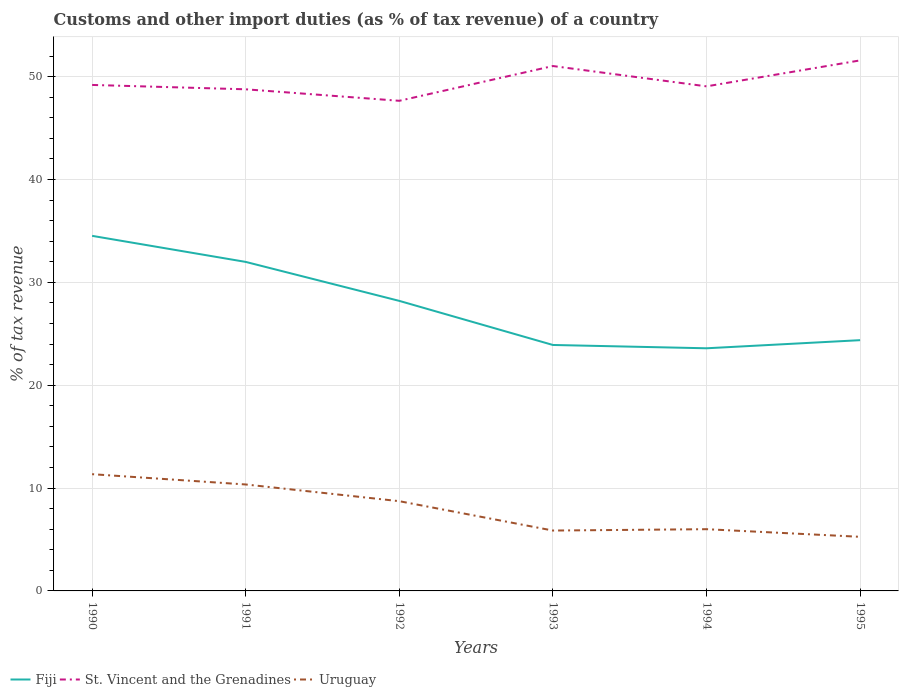Is the number of lines equal to the number of legend labels?
Offer a terse response. Yes. Across all years, what is the maximum percentage of tax revenue from customs in Uruguay?
Your response must be concise. 5.26. What is the total percentage of tax revenue from customs in St. Vincent and the Grenadines in the graph?
Give a very brief answer. -1.84. What is the difference between the highest and the second highest percentage of tax revenue from customs in Fiji?
Offer a very short reply. 10.93. What is the difference between the highest and the lowest percentage of tax revenue from customs in Uruguay?
Keep it short and to the point. 3. Is the percentage of tax revenue from customs in St. Vincent and the Grenadines strictly greater than the percentage of tax revenue from customs in Uruguay over the years?
Your answer should be very brief. No. How many lines are there?
Offer a very short reply. 3. Are the values on the major ticks of Y-axis written in scientific E-notation?
Provide a succinct answer. No. Does the graph contain any zero values?
Provide a short and direct response. No. Does the graph contain grids?
Your answer should be very brief. Yes. Where does the legend appear in the graph?
Ensure brevity in your answer.  Bottom left. What is the title of the graph?
Provide a succinct answer. Customs and other import duties (as % of tax revenue) of a country. What is the label or title of the X-axis?
Give a very brief answer. Years. What is the label or title of the Y-axis?
Your response must be concise. % of tax revenue. What is the % of tax revenue in Fiji in 1990?
Ensure brevity in your answer.  34.53. What is the % of tax revenue in St. Vincent and the Grenadines in 1990?
Offer a terse response. 49.2. What is the % of tax revenue of Uruguay in 1990?
Make the answer very short. 11.35. What is the % of tax revenue in Fiji in 1991?
Your answer should be very brief. 31.99. What is the % of tax revenue of St. Vincent and the Grenadines in 1991?
Keep it short and to the point. 48.78. What is the % of tax revenue of Uruguay in 1991?
Offer a terse response. 10.35. What is the % of tax revenue of Fiji in 1992?
Your response must be concise. 28.2. What is the % of tax revenue in St. Vincent and the Grenadines in 1992?
Your response must be concise. 47.66. What is the % of tax revenue of Uruguay in 1992?
Your answer should be compact. 8.73. What is the % of tax revenue in Fiji in 1993?
Provide a short and direct response. 23.92. What is the % of tax revenue in St. Vincent and the Grenadines in 1993?
Provide a short and direct response. 51.04. What is the % of tax revenue of Uruguay in 1993?
Ensure brevity in your answer.  5.87. What is the % of tax revenue in Fiji in 1994?
Ensure brevity in your answer.  23.59. What is the % of tax revenue in St. Vincent and the Grenadines in 1994?
Provide a short and direct response. 49.06. What is the % of tax revenue of Uruguay in 1994?
Your answer should be compact. 6. What is the % of tax revenue in Fiji in 1995?
Provide a succinct answer. 24.38. What is the % of tax revenue of St. Vincent and the Grenadines in 1995?
Provide a succinct answer. 51.59. What is the % of tax revenue of Uruguay in 1995?
Provide a succinct answer. 5.26. Across all years, what is the maximum % of tax revenue in Fiji?
Make the answer very short. 34.53. Across all years, what is the maximum % of tax revenue of St. Vincent and the Grenadines?
Give a very brief answer. 51.59. Across all years, what is the maximum % of tax revenue of Uruguay?
Ensure brevity in your answer.  11.35. Across all years, what is the minimum % of tax revenue in Fiji?
Provide a succinct answer. 23.59. Across all years, what is the minimum % of tax revenue of St. Vincent and the Grenadines?
Keep it short and to the point. 47.66. Across all years, what is the minimum % of tax revenue in Uruguay?
Offer a terse response. 5.26. What is the total % of tax revenue of Fiji in the graph?
Make the answer very short. 166.61. What is the total % of tax revenue of St. Vincent and the Grenadines in the graph?
Ensure brevity in your answer.  297.31. What is the total % of tax revenue of Uruguay in the graph?
Provide a succinct answer. 47.56. What is the difference between the % of tax revenue in Fiji in 1990 and that in 1991?
Your response must be concise. 2.53. What is the difference between the % of tax revenue of St. Vincent and the Grenadines in 1990 and that in 1991?
Your answer should be compact. 0.42. What is the difference between the % of tax revenue of Uruguay in 1990 and that in 1991?
Your answer should be very brief. 1. What is the difference between the % of tax revenue of Fiji in 1990 and that in 1992?
Provide a succinct answer. 6.32. What is the difference between the % of tax revenue of St. Vincent and the Grenadines in 1990 and that in 1992?
Your response must be concise. 1.54. What is the difference between the % of tax revenue in Uruguay in 1990 and that in 1992?
Offer a very short reply. 2.63. What is the difference between the % of tax revenue of Fiji in 1990 and that in 1993?
Ensure brevity in your answer.  10.61. What is the difference between the % of tax revenue of St. Vincent and the Grenadines in 1990 and that in 1993?
Provide a succinct answer. -1.84. What is the difference between the % of tax revenue in Uruguay in 1990 and that in 1993?
Provide a short and direct response. 5.48. What is the difference between the % of tax revenue in Fiji in 1990 and that in 1994?
Provide a short and direct response. 10.93. What is the difference between the % of tax revenue of St. Vincent and the Grenadines in 1990 and that in 1994?
Make the answer very short. 0.14. What is the difference between the % of tax revenue in Uruguay in 1990 and that in 1994?
Your response must be concise. 5.35. What is the difference between the % of tax revenue in Fiji in 1990 and that in 1995?
Make the answer very short. 10.14. What is the difference between the % of tax revenue of St. Vincent and the Grenadines in 1990 and that in 1995?
Provide a short and direct response. -2.39. What is the difference between the % of tax revenue of Uruguay in 1990 and that in 1995?
Your answer should be very brief. 6.09. What is the difference between the % of tax revenue of Fiji in 1991 and that in 1992?
Keep it short and to the point. 3.79. What is the difference between the % of tax revenue of St. Vincent and the Grenadines in 1991 and that in 1992?
Keep it short and to the point. 1.12. What is the difference between the % of tax revenue in Uruguay in 1991 and that in 1992?
Offer a terse response. 1.62. What is the difference between the % of tax revenue in Fiji in 1991 and that in 1993?
Your answer should be compact. 8.08. What is the difference between the % of tax revenue of St. Vincent and the Grenadines in 1991 and that in 1993?
Give a very brief answer. -2.26. What is the difference between the % of tax revenue in Uruguay in 1991 and that in 1993?
Make the answer very short. 4.48. What is the difference between the % of tax revenue in Fiji in 1991 and that in 1994?
Provide a short and direct response. 8.4. What is the difference between the % of tax revenue in St. Vincent and the Grenadines in 1991 and that in 1994?
Offer a terse response. -0.29. What is the difference between the % of tax revenue of Uruguay in 1991 and that in 1994?
Provide a short and direct response. 4.35. What is the difference between the % of tax revenue in Fiji in 1991 and that in 1995?
Provide a succinct answer. 7.61. What is the difference between the % of tax revenue of St. Vincent and the Grenadines in 1991 and that in 1995?
Provide a short and direct response. -2.81. What is the difference between the % of tax revenue in Uruguay in 1991 and that in 1995?
Ensure brevity in your answer.  5.09. What is the difference between the % of tax revenue in Fiji in 1992 and that in 1993?
Offer a terse response. 4.29. What is the difference between the % of tax revenue of St. Vincent and the Grenadines in 1992 and that in 1993?
Your answer should be very brief. -3.38. What is the difference between the % of tax revenue of Uruguay in 1992 and that in 1993?
Your response must be concise. 2.85. What is the difference between the % of tax revenue of Fiji in 1992 and that in 1994?
Your response must be concise. 4.61. What is the difference between the % of tax revenue in St. Vincent and the Grenadines in 1992 and that in 1994?
Offer a terse response. -1.4. What is the difference between the % of tax revenue of Uruguay in 1992 and that in 1994?
Ensure brevity in your answer.  2.72. What is the difference between the % of tax revenue of Fiji in 1992 and that in 1995?
Offer a terse response. 3.82. What is the difference between the % of tax revenue of St. Vincent and the Grenadines in 1992 and that in 1995?
Provide a short and direct response. -3.93. What is the difference between the % of tax revenue of Uruguay in 1992 and that in 1995?
Your response must be concise. 3.46. What is the difference between the % of tax revenue in Fiji in 1993 and that in 1994?
Your answer should be very brief. 0.32. What is the difference between the % of tax revenue of St. Vincent and the Grenadines in 1993 and that in 1994?
Give a very brief answer. 1.98. What is the difference between the % of tax revenue of Uruguay in 1993 and that in 1994?
Your response must be concise. -0.13. What is the difference between the % of tax revenue of Fiji in 1993 and that in 1995?
Provide a short and direct response. -0.47. What is the difference between the % of tax revenue of St. Vincent and the Grenadines in 1993 and that in 1995?
Provide a short and direct response. -0.55. What is the difference between the % of tax revenue in Uruguay in 1993 and that in 1995?
Offer a terse response. 0.61. What is the difference between the % of tax revenue of Fiji in 1994 and that in 1995?
Offer a terse response. -0.79. What is the difference between the % of tax revenue of St. Vincent and the Grenadines in 1994 and that in 1995?
Provide a succinct answer. -2.52. What is the difference between the % of tax revenue in Uruguay in 1994 and that in 1995?
Give a very brief answer. 0.74. What is the difference between the % of tax revenue in Fiji in 1990 and the % of tax revenue in St. Vincent and the Grenadines in 1991?
Offer a very short reply. -14.25. What is the difference between the % of tax revenue of Fiji in 1990 and the % of tax revenue of Uruguay in 1991?
Offer a terse response. 24.18. What is the difference between the % of tax revenue of St. Vincent and the Grenadines in 1990 and the % of tax revenue of Uruguay in 1991?
Provide a short and direct response. 38.85. What is the difference between the % of tax revenue in Fiji in 1990 and the % of tax revenue in St. Vincent and the Grenadines in 1992?
Ensure brevity in your answer.  -13.13. What is the difference between the % of tax revenue of Fiji in 1990 and the % of tax revenue of Uruguay in 1992?
Provide a succinct answer. 25.8. What is the difference between the % of tax revenue of St. Vincent and the Grenadines in 1990 and the % of tax revenue of Uruguay in 1992?
Provide a short and direct response. 40.47. What is the difference between the % of tax revenue of Fiji in 1990 and the % of tax revenue of St. Vincent and the Grenadines in 1993?
Your answer should be very brief. -16.51. What is the difference between the % of tax revenue in Fiji in 1990 and the % of tax revenue in Uruguay in 1993?
Your answer should be compact. 28.66. What is the difference between the % of tax revenue in St. Vincent and the Grenadines in 1990 and the % of tax revenue in Uruguay in 1993?
Give a very brief answer. 43.33. What is the difference between the % of tax revenue of Fiji in 1990 and the % of tax revenue of St. Vincent and the Grenadines in 1994?
Your answer should be compact. -14.54. What is the difference between the % of tax revenue in Fiji in 1990 and the % of tax revenue in Uruguay in 1994?
Give a very brief answer. 28.52. What is the difference between the % of tax revenue of St. Vincent and the Grenadines in 1990 and the % of tax revenue of Uruguay in 1994?
Make the answer very short. 43.2. What is the difference between the % of tax revenue of Fiji in 1990 and the % of tax revenue of St. Vincent and the Grenadines in 1995?
Make the answer very short. -17.06. What is the difference between the % of tax revenue of Fiji in 1990 and the % of tax revenue of Uruguay in 1995?
Provide a succinct answer. 29.26. What is the difference between the % of tax revenue in St. Vincent and the Grenadines in 1990 and the % of tax revenue in Uruguay in 1995?
Provide a short and direct response. 43.94. What is the difference between the % of tax revenue in Fiji in 1991 and the % of tax revenue in St. Vincent and the Grenadines in 1992?
Ensure brevity in your answer.  -15.67. What is the difference between the % of tax revenue of Fiji in 1991 and the % of tax revenue of Uruguay in 1992?
Give a very brief answer. 23.27. What is the difference between the % of tax revenue in St. Vincent and the Grenadines in 1991 and the % of tax revenue in Uruguay in 1992?
Your answer should be very brief. 40.05. What is the difference between the % of tax revenue in Fiji in 1991 and the % of tax revenue in St. Vincent and the Grenadines in 1993?
Offer a terse response. -19.05. What is the difference between the % of tax revenue in Fiji in 1991 and the % of tax revenue in Uruguay in 1993?
Your answer should be compact. 26.12. What is the difference between the % of tax revenue of St. Vincent and the Grenadines in 1991 and the % of tax revenue of Uruguay in 1993?
Your answer should be very brief. 42.9. What is the difference between the % of tax revenue of Fiji in 1991 and the % of tax revenue of St. Vincent and the Grenadines in 1994?
Keep it short and to the point. -17.07. What is the difference between the % of tax revenue in Fiji in 1991 and the % of tax revenue in Uruguay in 1994?
Provide a succinct answer. 25.99. What is the difference between the % of tax revenue in St. Vincent and the Grenadines in 1991 and the % of tax revenue in Uruguay in 1994?
Give a very brief answer. 42.77. What is the difference between the % of tax revenue of Fiji in 1991 and the % of tax revenue of St. Vincent and the Grenadines in 1995?
Your answer should be very brief. -19.59. What is the difference between the % of tax revenue of Fiji in 1991 and the % of tax revenue of Uruguay in 1995?
Offer a terse response. 26.73. What is the difference between the % of tax revenue in St. Vincent and the Grenadines in 1991 and the % of tax revenue in Uruguay in 1995?
Your response must be concise. 43.51. What is the difference between the % of tax revenue of Fiji in 1992 and the % of tax revenue of St. Vincent and the Grenadines in 1993?
Your response must be concise. -22.84. What is the difference between the % of tax revenue in Fiji in 1992 and the % of tax revenue in Uruguay in 1993?
Your answer should be very brief. 22.33. What is the difference between the % of tax revenue in St. Vincent and the Grenadines in 1992 and the % of tax revenue in Uruguay in 1993?
Ensure brevity in your answer.  41.79. What is the difference between the % of tax revenue in Fiji in 1992 and the % of tax revenue in St. Vincent and the Grenadines in 1994?
Provide a short and direct response. -20.86. What is the difference between the % of tax revenue of Fiji in 1992 and the % of tax revenue of Uruguay in 1994?
Offer a terse response. 22.2. What is the difference between the % of tax revenue in St. Vincent and the Grenadines in 1992 and the % of tax revenue in Uruguay in 1994?
Give a very brief answer. 41.65. What is the difference between the % of tax revenue of Fiji in 1992 and the % of tax revenue of St. Vincent and the Grenadines in 1995?
Keep it short and to the point. -23.38. What is the difference between the % of tax revenue of Fiji in 1992 and the % of tax revenue of Uruguay in 1995?
Keep it short and to the point. 22.94. What is the difference between the % of tax revenue in St. Vincent and the Grenadines in 1992 and the % of tax revenue in Uruguay in 1995?
Provide a succinct answer. 42.4. What is the difference between the % of tax revenue of Fiji in 1993 and the % of tax revenue of St. Vincent and the Grenadines in 1994?
Provide a short and direct response. -25.15. What is the difference between the % of tax revenue of Fiji in 1993 and the % of tax revenue of Uruguay in 1994?
Keep it short and to the point. 17.91. What is the difference between the % of tax revenue of St. Vincent and the Grenadines in 1993 and the % of tax revenue of Uruguay in 1994?
Offer a very short reply. 45.04. What is the difference between the % of tax revenue of Fiji in 1993 and the % of tax revenue of St. Vincent and the Grenadines in 1995?
Give a very brief answer. -27.67. What is the difference between the % of tax revenue in Fiji in 1993 and the % of tax revenue in Uruguay in 1995?
Your answer should be very brief. 18.65. What is the difference between the % of tax revenue of St. Vincent and the Grenadines in 1993 and the % of tax revenue of Uruguay in 1995?
Your answer should be very brief. 45.78. What is the difference between the % of tax revenue in Fiji in 1994 and the % of tax revenue in St. Vincent and the Grenadines in 1995?
Provide a short and direct response. -27.99. What is the difference between the % of tax revenue of Fiji in 1994 and the % of tax revenue of Uruguay in 1995?
Keep it short and to the point. 18.33. What is the difference between the % of tax revenue in St. Vincent and the Grenadines in 1994 and the % of tax revenue in Uruguay in 1995?
Offer a very short reply. 43.8. What is the average % of tax revenue of Fiji per year?
Provide a succinct answer. 27.77. What is the average % of tax revenue in St. Vincent and the Grenadines per year?
Provide a succinct answer. 49.55. What is the average % of tax revenue in Uruguay per year?
Offer a terse response. 7.93. In the year 1990, what is the difference between the % of tax revenue in Fiji and % of tax revenue in St. Vincent and the Grenadines?
Provide a short and direct response. -14.67. In the year 1990, what is the difference between the % of tax revenue in Fiji and % of tax revenue in Uruguay?
Offer a terse response. 23.18. In the year 1990, what is the difference between the % of tax revenue of St. Vincent and the Grenadines and % of tax revenue of Uruguay?
Your response must be concise. 37.85. In the year 1991, what is the difference between the % of tax revenue in Fiji and % of tax revenue in St. Vincent and the Grenadines?
Your response must be concise. -16.78. In the year 1991, what is the difference between the % of tax revenue of Fiji and % of tax revenue of Uruguay?
Keep it short and to the point. 21.64. In the year 1991, what is the difference between the % of tax revenue in St. Vincent and the Grenadines and % of tax revenue in Uruguay?
Make the answer very short. 38.42. In the year 1992, what is the difference between the % of tax revenue in Fiji and % of tax revenue in St. Vincent and the Grenadines?
Give a very brief answer. -19.46. In the year 1992, what is the difference between the % of tax revenue of Fiji and % of tax revenue of Uruguay?
Make the answer very short. 19.48. In the year 1992, what is the difference between the % of tax revenue of St. Vincent and the Grenadines and % of tax revenue of Uruguay?
Give a very brief answer. 38.93. In the year 1993, what is the difference between the % of tax revenue of Fiji and % of tax revenue of St. Vincent and the Grenadines?
Provide a succinct answer. -27.12. In the year 1993, what is the difference between the % of tax revenue of Fiji and % of tax revenue of Uruguay?
Your answer should be compact. 18.04. In the year 1993, what is the difference between the % of tax revenue of St. Vincent and the Grenadines and % of tax revenue of Uruguay?
Offer a terse response. 45.17. In the year 1994, what is the difference between the % of tax revenue in Fiji and % of tax revenue in St. Vincent and the Grenadines?
Provide a short and direct response. -25.47. In the year 1994, what is the difference between the % of tax revenue of Fiji and % of tax revenue of Uruguay?
Give a very brief answer. 17.59. In the year 1994, what is the difference between the % of tax revenue in St. Vincent and the Grenadines and % of tax revenue in Uruguay?
Provide a succinct answer. 43.06. In the year 1995, what is the difference between the % of tax revenue of Fiji and % of tax revenue of St. Vincent and the Grenadines?
Your answer should be very brief. -27.2. In the year 1995, what is the difference between the % of tax revenue of Fiji and % of tax revenue of Uruguay?
Keep it short and to the point. 19.12. In the year 1995, what is the difference between the % of tax revenue in St. Vincent and the Grenadines and % of tax revenue in Uruguay?
Offer a terse response. 46.32. What is the ratio of the % of tax revenue in Fiji in 1990 to that in 1991?
Your answer should be very brief. 1.08. What is the ratio of the % of tax revenue of St. Vincent and the Grenadines in 1990 to that in 1991?
Make the answer very short. 1.01. What is the ratio of the % of tax revenue in Uruguay in 1990 to that in 1991?
Ensure brevity in your answer.  1.1. What is the ratio of the % of tax revenue in Fiji in 1990 to that in 1992?
Your answer should be compact. 1.22. What is the ratio of the % of tax revenue of St. Vincent and the Grenadines in 1990 to that in 1992?
Give a very brief answer. 1.03. What is the ratio of the % of tax revenue in Uruguay in 1990 to that in 1992?
Make the answer very short. 1.3. What is the ratio of the % of tax revenue of Fiji in 1990 to that in 1993?
Make the answer very short. 1.44. What is the ratio of the % of tax revenue in St. Vincent and the Grenadines in 1990 to that in 1993?
Ensure brevity in your answer.  0.96. What is the ratio of the % of tax revenue of Uruguay in 1990 to that in 1993?
Make the answer very short. 1.93. What is the ratio of the % of tax revenue of Fiji in 1990 to that in 1994?
Provide a succinct answer. 1.46. What is the ratio of the % of tax revenue of Uruguay in 1990 to that in 1994?
Ensure brevity in your answer.  1.89. What is the ratio of the % of tax revenue in Fiji in 1990 to that in 1995?
Keep it short and to the point. 1.42. What is the ratio of the % of tax revenue of St. Vincent and the Grenadines in 1990 to that in 1995?
Your answer should be very brief. 0.95. What is the ratio of the % of tax revenue in Uruguay in 1990 to that in 1995?
Your answer should be very brief. 2.16. What is the ratio of the % of tax revenue of Fiji in 1991 to that in 1992?
Ensure brevity in your answer.  1.13. What is the ratio of the % of tax revenue of St. Vincent and the Grenadines in 1991 to that in 1992?
Your response must be concise. 1.02. What is the ratio of the % of tax revenue in Uruguay in 1991 to that in 1992?
Offer a terse response. 1.19. What is the ratio of the % of tax revenue in Fiji in 1991 to that in 1993?
Ensure brevity in your answer.  1.34. What is the ratio of the % of tax revenue in St. Vincent and the Grenadines in 1991 to that in 1993?
Offer a very short reply. 0.96. What is the ratio of the % of tax revenue of Uruguay in 1991 to that in 1993?
Your response must be concise. 1.76. What is the ratio of the % of tax revenue of Fiji in 1991 to that in 1994?
Give a very brief answer. 1.36. What is the ratio of the % of tax revenue in Uruguay in 1991 to that in 1994?
Ensure brevity in your answer.  1.72. What is the ratio of the % of tax revenue of Fiji in 1991 to that in 1995?
Keep it short and to the point. 1.31. What is the ratio of the % of tax revenue of St. Vincent and the Grenadines in 1991 to that in 1995?
Offer a terse response. 0.95. What is the ratio of the % of tax revenue in Uruguay in 1991 to that in 1995?
Offer a very short reply. 1.97. What is the ratio of the % of tax revenue in Fiji in 1992 to that in 1993?
Keep it short and to the point. 1.18. What is the ratio of the % of tax revenue in St. Vincent and the Grenadines in 1992 to that in 1993?
Your response must be concise. 0.93. What is the ratio of the % of tax revenue in Uruguay in 1992 to that in 1993?
Offer a terse response. 1.49. What is the ratio of the % of tax revenue in Fiji in 1992 to that in 1994?
Provide a succinct answer. 1.2. What is the ratio of the % of tax revenue in St. Vincent and the Grenadines in 1992 to that in 1994?
Your answer should be very brief. 0.97. What is the ratio of the % of tax revenue in Uruguay in 1992 to that in 1994?
Give a very brief answer. 1.45. What is the ratio of the % of tax revenue in Fiji in 1992 to that in 1995?
Keep it short and to the point. 1.16. What is the ratio of the % of tax revenue in St. Vincent and the Grenadines in 1992 to that in 1995?
Offer a very short reply. 0.92. What is the ratio of the % of tax revenue in Uruguay in 1992 to that in 1995?
Your response must be concise. 1.66. What is the ratio of the % of tax revenue of Fiji in 1993 to that in 1994?
Your response must be concise. 1.01. What is the ratio of the % of tax revenue of St. Vincent and the Grenadines in 1993 to that in 1994?
Make the answer very short. 1.04. What is the ratio of the % of tax revenue in Uruguay in 1993 to that in 1994?
Keep it short and to the point. 0.98. What is the ratio of the % of tax revenue of Fiji in 1993 to that in 1995?
Offer a terse response. 0.98. What is the ratio of the % of tax revenue of Uruguay in 1993 to that in 1995?
Give a very brief answer. 1.12. What is the ratio of the % of tax revenue in Fiji in 1994 to that in 1995?
Your response must be concise. 0.97. What is the ratio of the % of tax revenue in St. Vincent and the Grenadines in 1994 to that in 1995?
Ensure brevity in your answer.  0.95. What is the ratio of the % of tax revenue in Uruguay in 1994 to that in 1995?
Your response must be concise. 1.14. What is the difference between the highest and the second highest % of tax revenue in Fiji?
Your answer should be compact. 2.53. What is the difference between the highest and the second highest % of tax revenue in St. Vincent and the Grenadines?
Your answer should be very brief. 0.55. What is the difference between the highest and the second highest % of tax revenue of Uruguay?
Ensure brevity in your answer.  1. What is the difference between the highest and the lowest % of tax revenue in Fiji?
Your answer should be very brief. 10.93. What is the difference between the highest and the lowest % of tax revenue in St. Vincent and the Grenadines?
Make the answer very short. 3.93. What is the difference between the highest and the lowest % of tax revenue of Uruguay?
Keep it short and to the point. 6.09. 